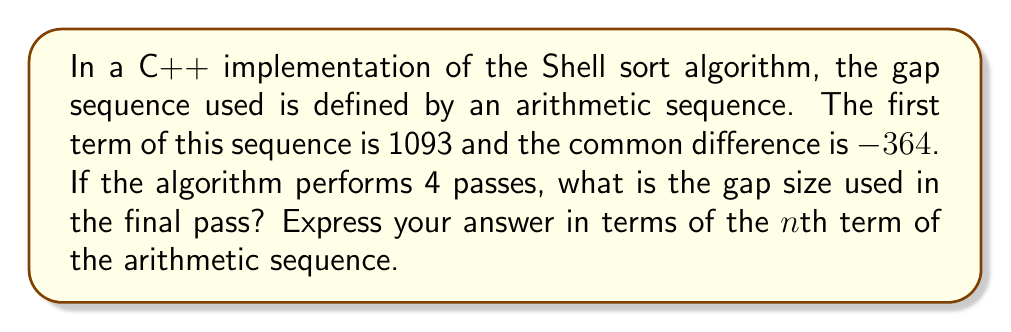Provide a solution to this math problem. Let's approach this step-by-step:

1) The general form of an arithmetic sequence is:

   $$a_n = a_1 + (n-1)d$$

   where $a_n$ is the nth term, $a_1$ is the first term, $n$ is the position of the term, and $d$ is the common difference.

2) We are given:
   - $a_1 = 1093$ (first term)
   - $d = -364$ (common difference)
   - We need to find the 4th term (as there are 4 passes)

3) Substituting these values into our formula:

   $$a_4 = 1093 + (4-1)(-364)$$

4) Simplify:
   $$a_4 = 1093 + (3)(-364)$$
   $$a_4 = 1093 - 1092$$
   $$a_4 = 1$$

5) Therefore, the gap size used in the final pass is the 4th term of the sequence, which is 1.

6) In terms of the nth term of the arithmetic sequence, this can be expressed as:

   $$a_n = 1093 + (n-1)(-364)$$
   $$a_n = 1093 - 364n + 364$$
   $$a_n = 1457 - 364n$$
Answer: $a_n = 1457 - 364n$ 